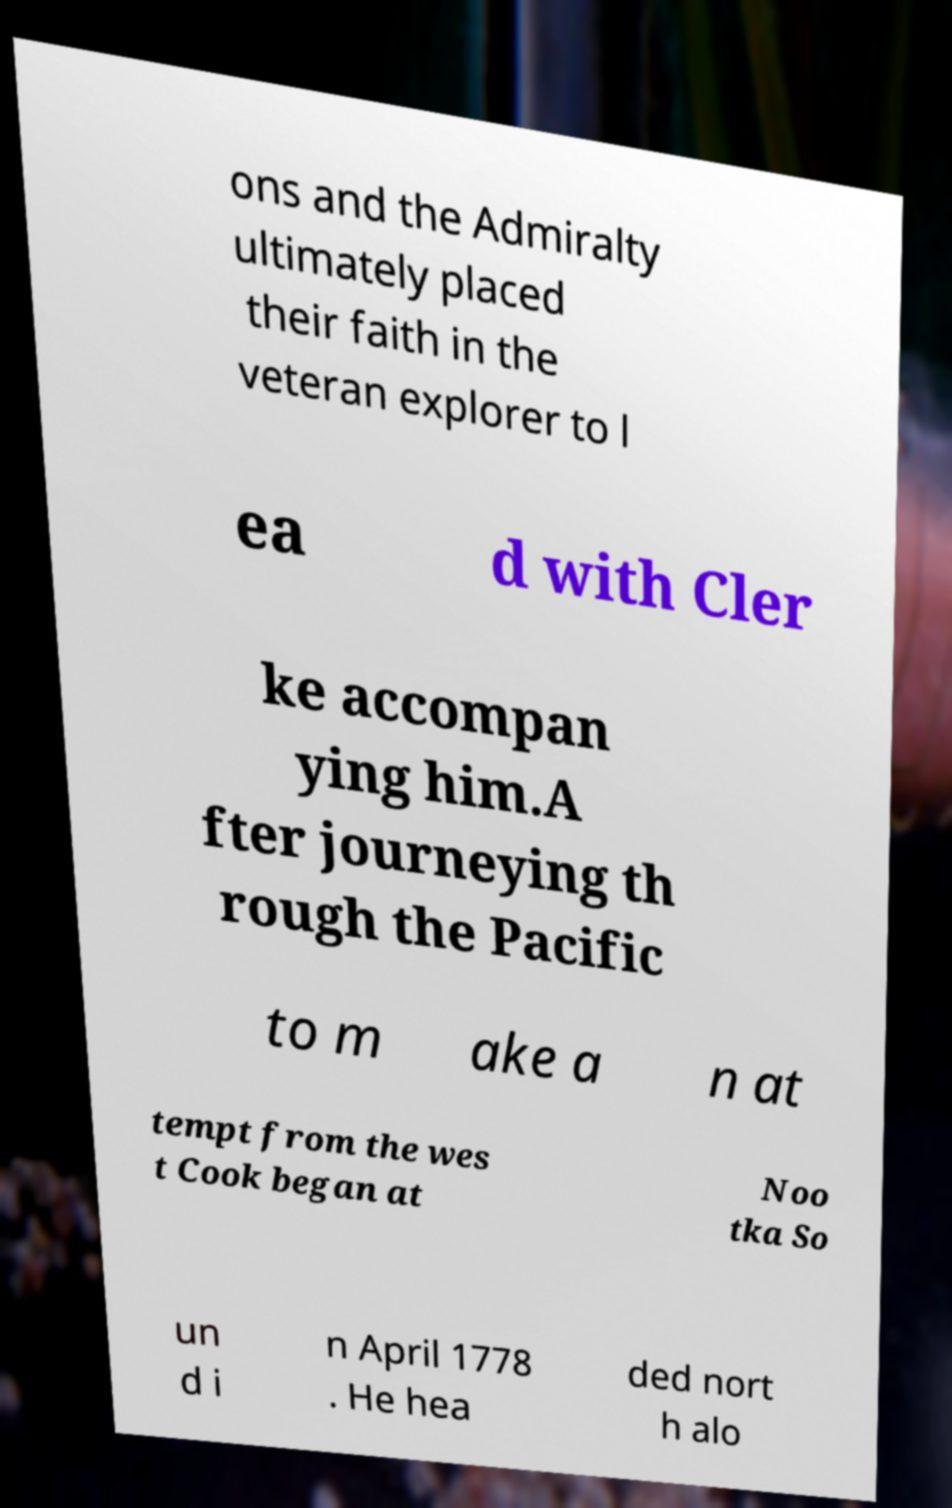Please identify and transcribe the text found in this image. ons and the Admiralty ultimately placed their faith in the veteran explorer to l ea d with Cler ke accompan ying him.A fter journeying th rough the Pacific to m ake a n at tempt from the wes t Cook began at Noo tka So un d i n April 1778 . He hea ded nort h alo 